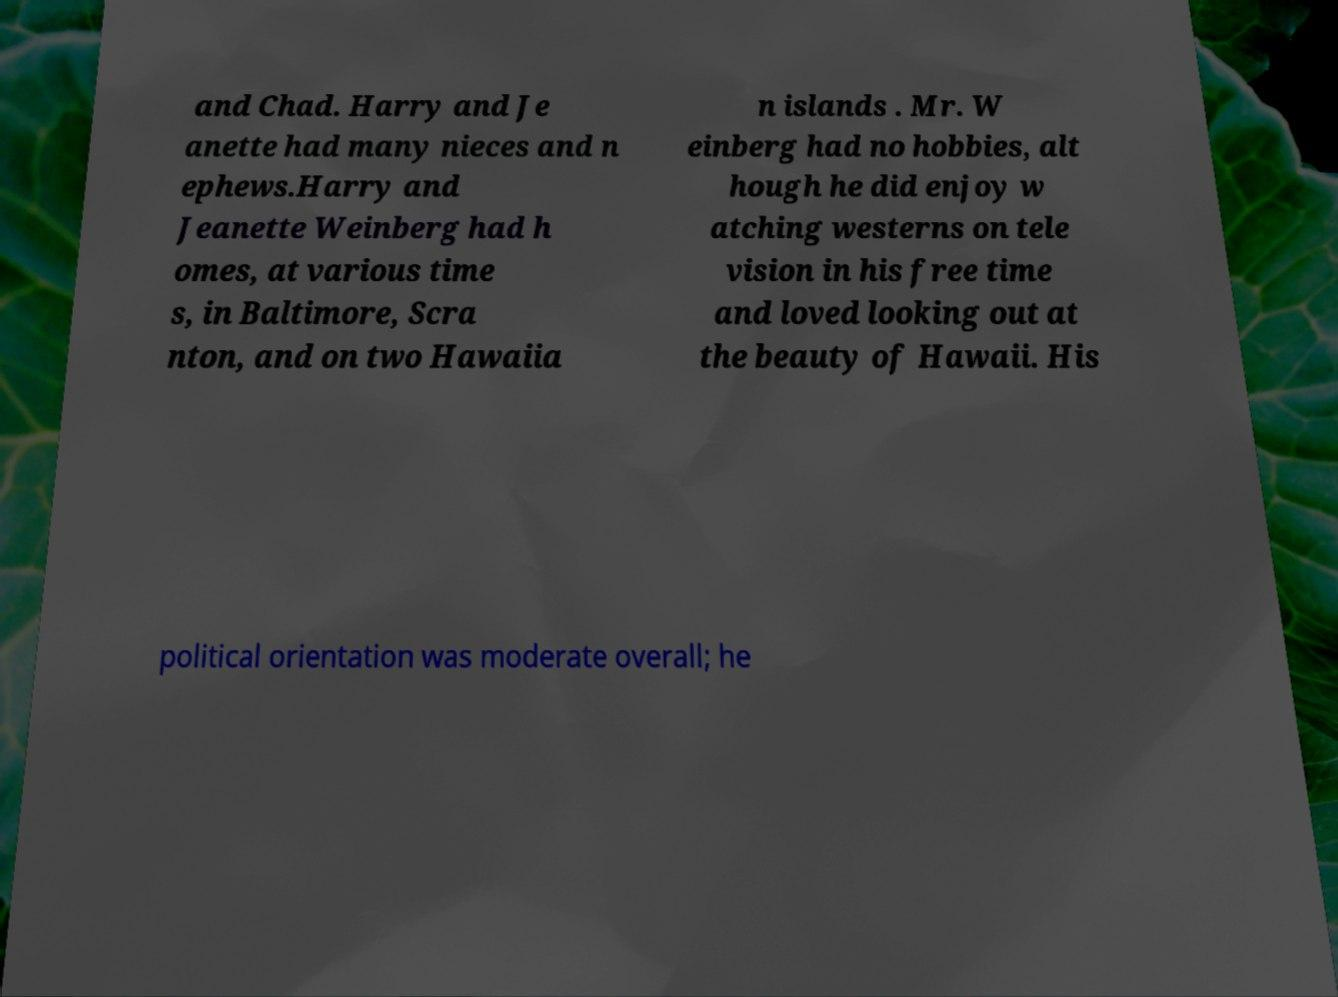Can you read and provide the text displayed in the image?This photo seems to have some interesting text. Can you extract and type it out for me? and Chad. Harry and Je anette had many nieces and n ephews.Harry and Jeanette Weinberg had h omes, at various time s, in Baltimore, Scra nton, and on two Hawaiia n islands . Mr. W einberg had no hobbies, alt hough he did enjoy w atching westerns on tele vision in his free time and loved looking out at the beauty of Hawaii. His political orientation was moderate overall; he 